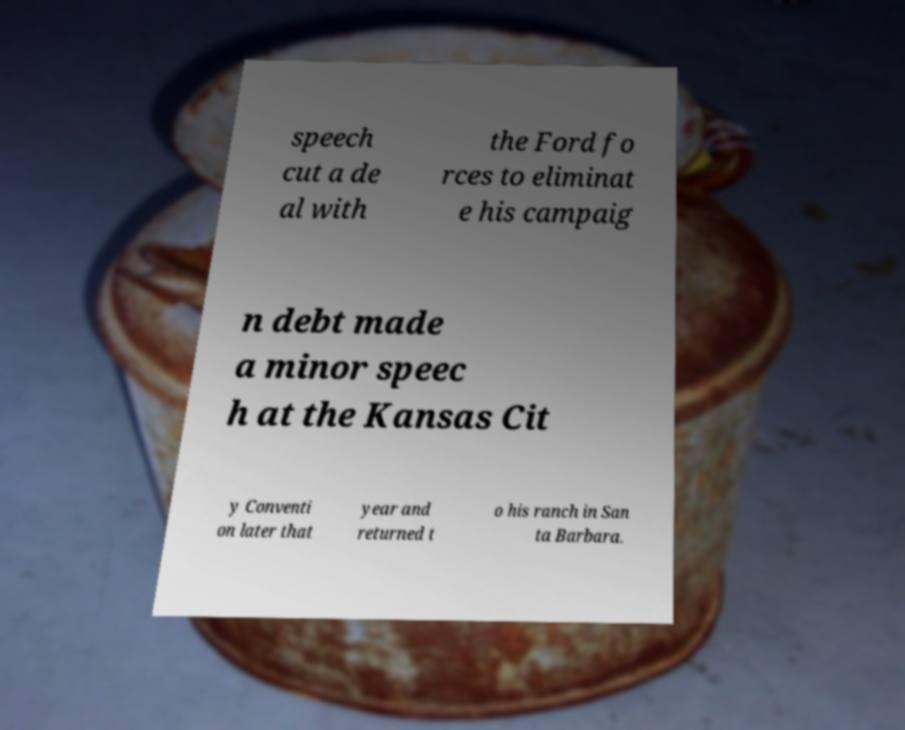Could you extract and type out the text from this image? speech cut a de al with the Ford fo rces to eliminat e his campaig n debt made a minor speec h at the Kansas Cit y Conventi on later that year and returned t o his ranch in San ta Barbara. 